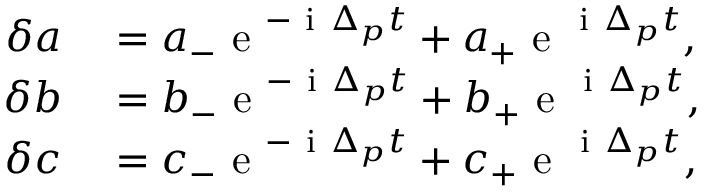<formula> <loc_0><loc_0><loc_500><loc_500>\begin{array} { r l } { \delta a } & = a _ { - } e ^ { - i \Delta _ { p } t } + a _ { + } e ^ { i \Delta _ { p } t } , } \\ { \delta b } & = b _ { - } e ^ { - i \Delta _ { p } t } + b _ { + } e ^ { i \Delta _ { p } t } , } \\ { \delta c } & = c _ { - } e ^ { - i \Delta _ { p } t } + c _ { + } e ^ { i \Delta _ { p } t } , } \end{array}</formula> 